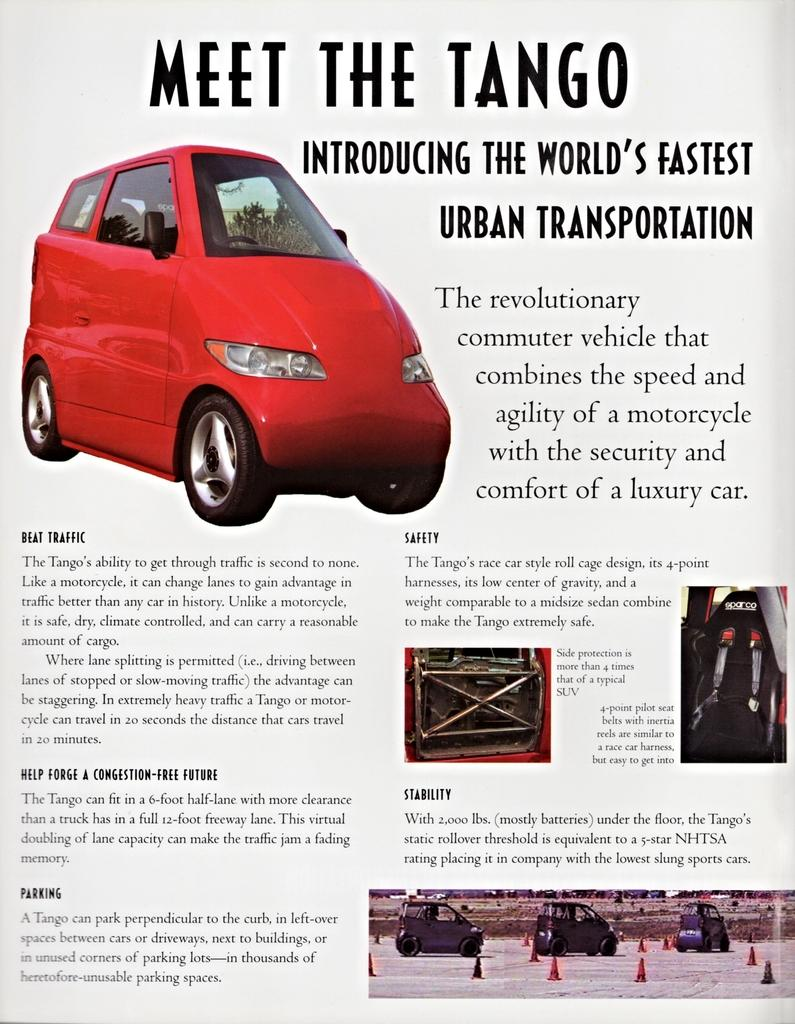How many frogs can be seen drinking wine from an eye in the image? There is no image provided, and therefore no frogs, wine, or eyes can be observed. 